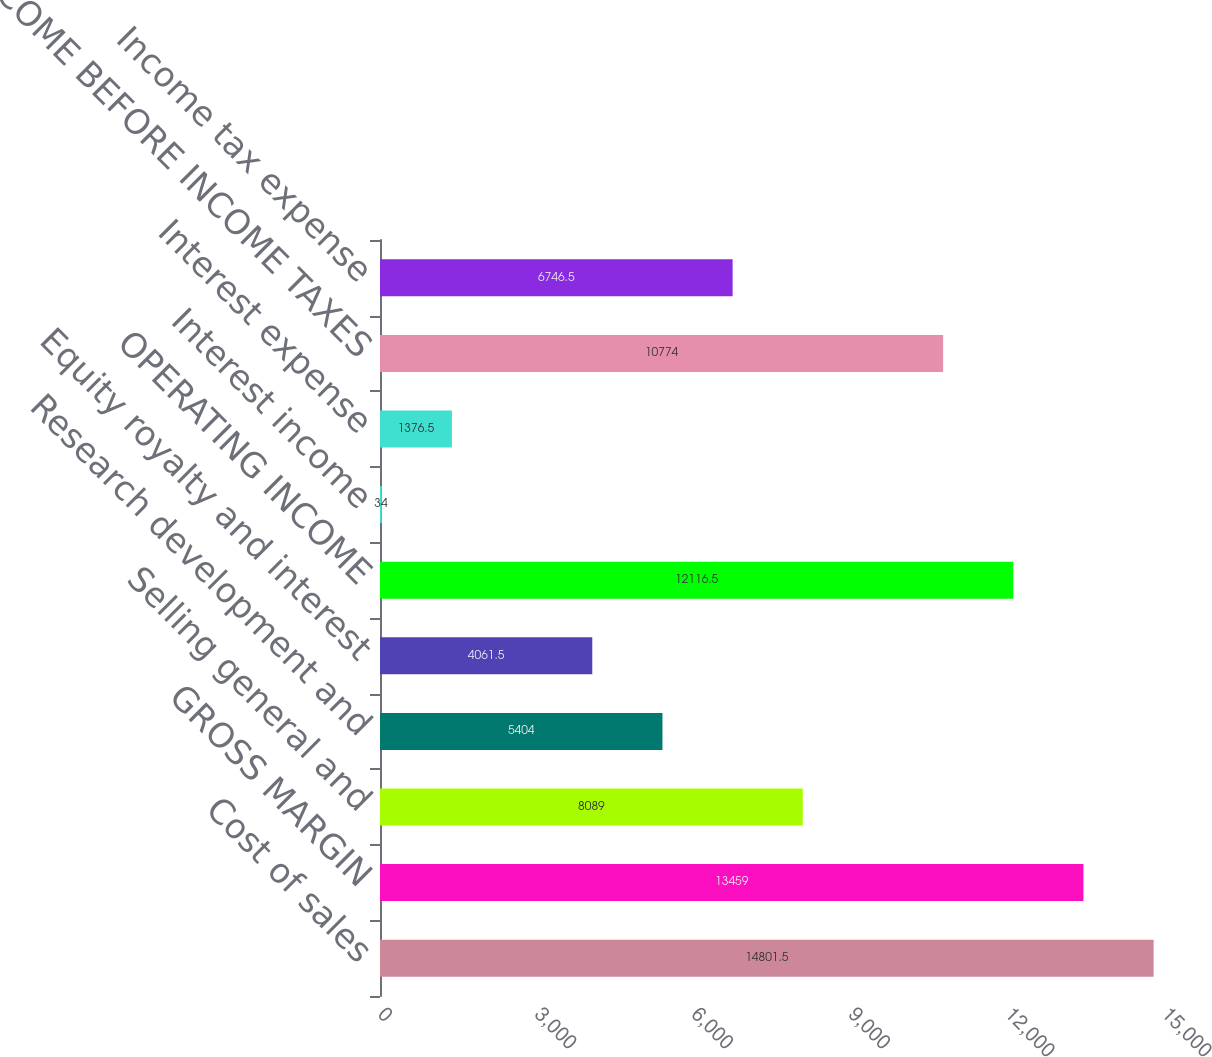Convert chart to OTSL. <chart><loc_0><loc_0><loc_500><loc_500><bar_chart><fcel>Cost of sales<fcel>GROSS MARGIN<fcel>Selling general and<fcel>Research development and<fcel>Equity royalty and interest<fcel>OPERATING INCOME<fcel>Interest income<fcel>Interest expense<fcel>INCOME BEFORE INCOME TAXES<fcel>Income tax expense<nl><fcel>14801.5<fcel>13459<fcel>8089<fcel>5404<fcel>4061.5<fcel>12116.5<fcel>34<fcel>1376.5<fcel>10774<fcel>6746.5<nl></chart> 